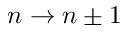<formula> <loc_0><loc_0><loc_500><loc_500>n \rightarrow n \pm 1</formula> 